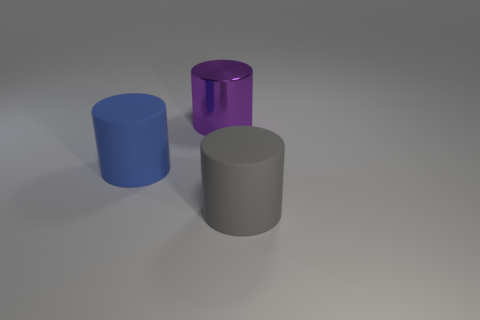Is the shape of the big purple shiny object the same as the blue matte thing?
Keep it short and to the point. Yes. There is a cylinder that is both on the left side of the gray cylinder and right of the big blue thing; what is its size?
Your answer should be compact. Large. There is a purple thing that is the same shape as the big gray object; what is it made of?
Provide a short and direct response. Metal. There is a large purple thing that is on the left side of the large thing in front of the blue object; what is its material?
Give a very brief answer. Metal. Is the shape of the metallic thing the same as the thing that is in front of the large blue rubber thing?
Your answer should be compact. Yes. What number of shiny things are either red blocks or blue objects?
Make the answer very short. 0. What color is the large rubber thing to the right of the matte cylinder that is behind the large gray object on the right side of the big blue rubber cylinder?
Your answer should be very brief. Gray. How many other objects are the same material as the large purple thing?
Make the answer very short. 0. Do the gray matte object that is on the right side of the big purple shiny cylinder and the large blue rubber thing have the same shape?
Offer a very short reply. Yes. How many small objects are either yellow rubber cubes or gray objects?
Your answer should be compact. 0. 